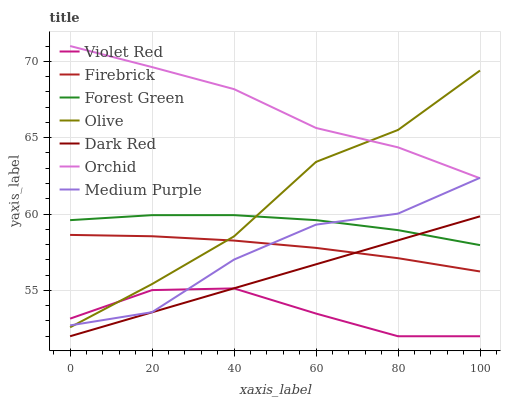Does Violet Red have the minimum area under the curve?
Answer yes or no. Yes. Does Orchid have the maximum area under the curve?
Answer yes or no. Yes. Does Dark Red have the minimum area under the curve?
Answer yes or no. No. Does Dark Red have the maximum area under the curve?
Answer yes or no. No. Is Dark Red the smoothest?
Answer yes or no. Yes. Is Medium Purple the roughest?
Answer yes or no. Yes. Is Firebrick the smoothest?
Answer yes or no. No. Is Firebrick the roughest?
Answer yes or no. No. Does Violet Red have the lowest value?
Answer yes or no. Yes. Does Firebrick have the lowest value?
Answer yes or no. No. Does Orchid have the highest value?
Answer yes or no. Yes. Does Dark Red have the highest value?
Answer yes or no. No. Is Dark Red less than Orchid?
Answer yes or no. Yes. Is Medium Purple greater than Dark Red?
Answer yes or no. Yes. Does Violet Red intersect Medium Purple?
Answer yes or no. Yes. Is Violet Red less than Medium Purple?
Answer yes or no. No. Is Violet Red greater than Medium Purple?
Answer yes or no. No. Does Dark Red intersect Orchid?
Answer yes or no. No. 